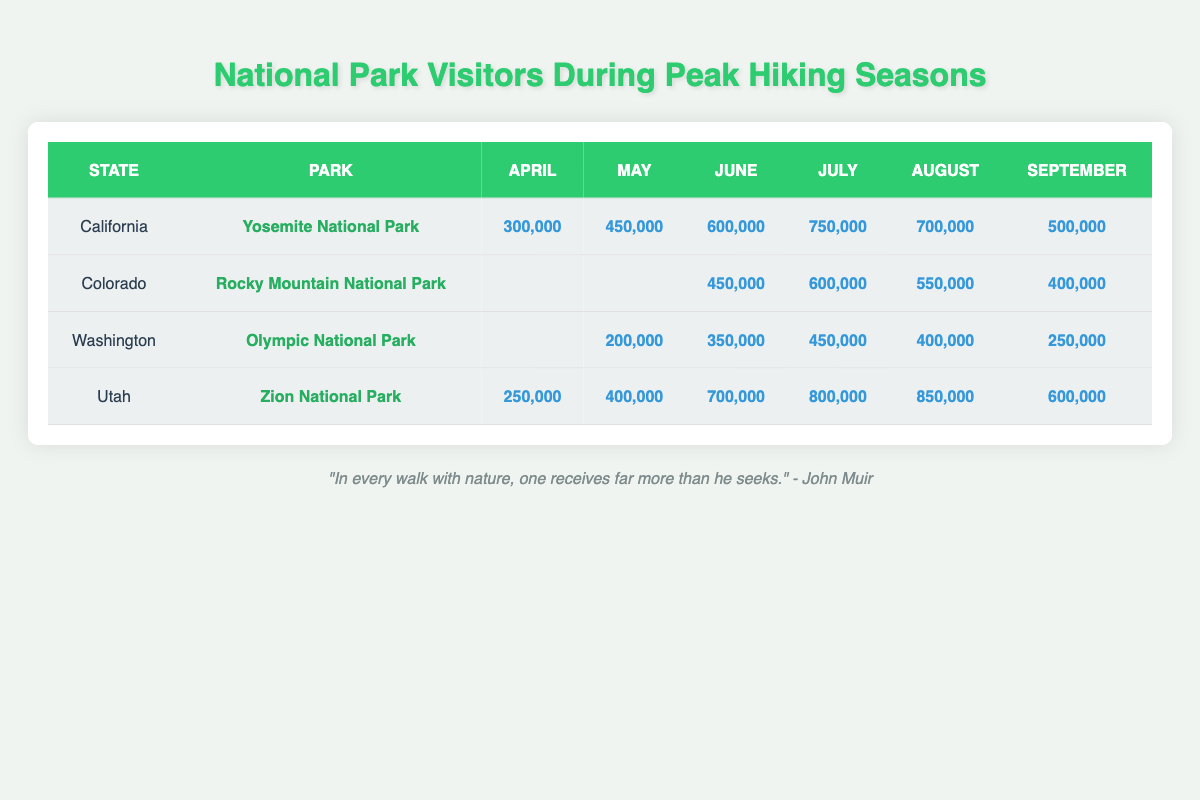What's the highest number of visitors recorded at Yosemite National Park? The maximum visitors are seen in July with 750,000 visitors. I refer to the row under California for Yosemite National Park and look at the July column to find this number.
Answer: 750,000 Which month had the lowest number of visitors at Zion National Park? At Zion National Park, the month with the lowest visitors is April, with 250,000 recorded. This is found by examining the visitor counts for each month listed for Zion National Park in the table.
Answer: 250,000 How many visitors did Olympic National Park have in June? The visitor count for Olympic National Park in June is 350,000. This number is located directly in the June column for the Washington park listing.
Answer: 350,000 What is the total number of visitors to Rocky Mountain National Park during July and August combined? To calculate the total visitors for July (600,000) and August (550,000), I add these two amounts together: 600,000 + 550,000 = 1,150,000. This requires referencing the counts for both months in the Colorado row.
Answer: 1,150,000 In which park was the average number of visitors from June to August the highest? First, I calculate the average number of visitors for each park from June to August: Yosemite (600,000 + 750,000 + 700,000) / 3 = 683,333; Rocky Mountain (450,000 + 600,000 + 550,000) / 3 = 533,333; Olympic (350,000 + 450,000 + 400,000) / 3 = 400,000; Zion (700,000 + 800,000 + 850,000) / 3 = 783,333. Comparing these averages, Zion National Park has the highest average with 783,333. This involves calculating the averages for each park and then comparing the results.
Answer: Zion National Park Is there any month where Olympic National Park had more visitors than Yosemite National Park? By comparing the visitor counts, Olympic National Park had fewer visitors than Yosemite National Park in each overlapping month (May: 200,000 vs. 450,000; June: 350,000 vs. 600,000; July: 450,000 vs. 750,000; August: 400,000 vs. 700,000). This requires checking each month’s counts side by side.
Answer: No What was the difference in visitor numbers between July and August for Zion National Park? For Zion National Park, the visitor count is 800,000 in July and 850,000 in August. The difference is calculated by subtracting July's count from August’s: 850,000 - 800,000 = 50,000. This involves simple subtraction of the two monthly values.
Answer: 50,000 Which park had the highest number of visitors in April? In April, Zion National Park had 250,000 visitors, while Yosemite had 300,000. Therefore, the park with the highest visitors is Yosemite National Park with 300,000. This requires checking the counts for both parks in the April column.
Answer: Yosemite National Park What is the total number of visitors to all parks combined in August? The August totals for each park are Yosemite (700,000), Rocky Mountain (550,000), Olympic (400,000), and Zion (850,000). When I add these amounts together: 700,000 + 550,000 + 400,000 + 850,000 = 2,500,000 total visitors. This is done by summing the August counts for each park.
Answer: 2,500,000 